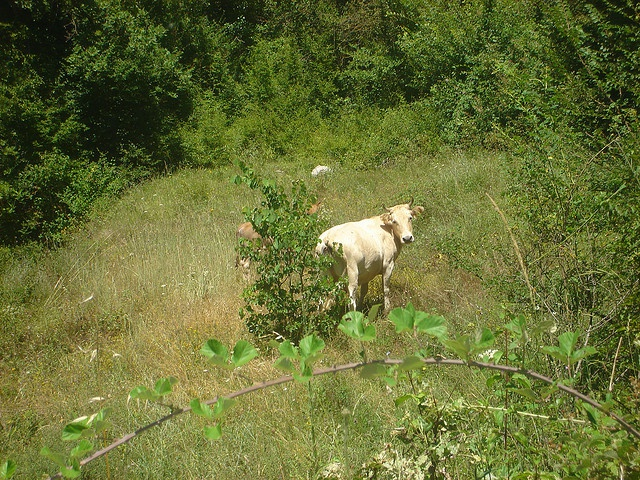Describe the objects in this image and their specific colors. I can see cow in black, beige, olive, khaki, and tan tones and cow in black, tan, and olive tones in this image. 